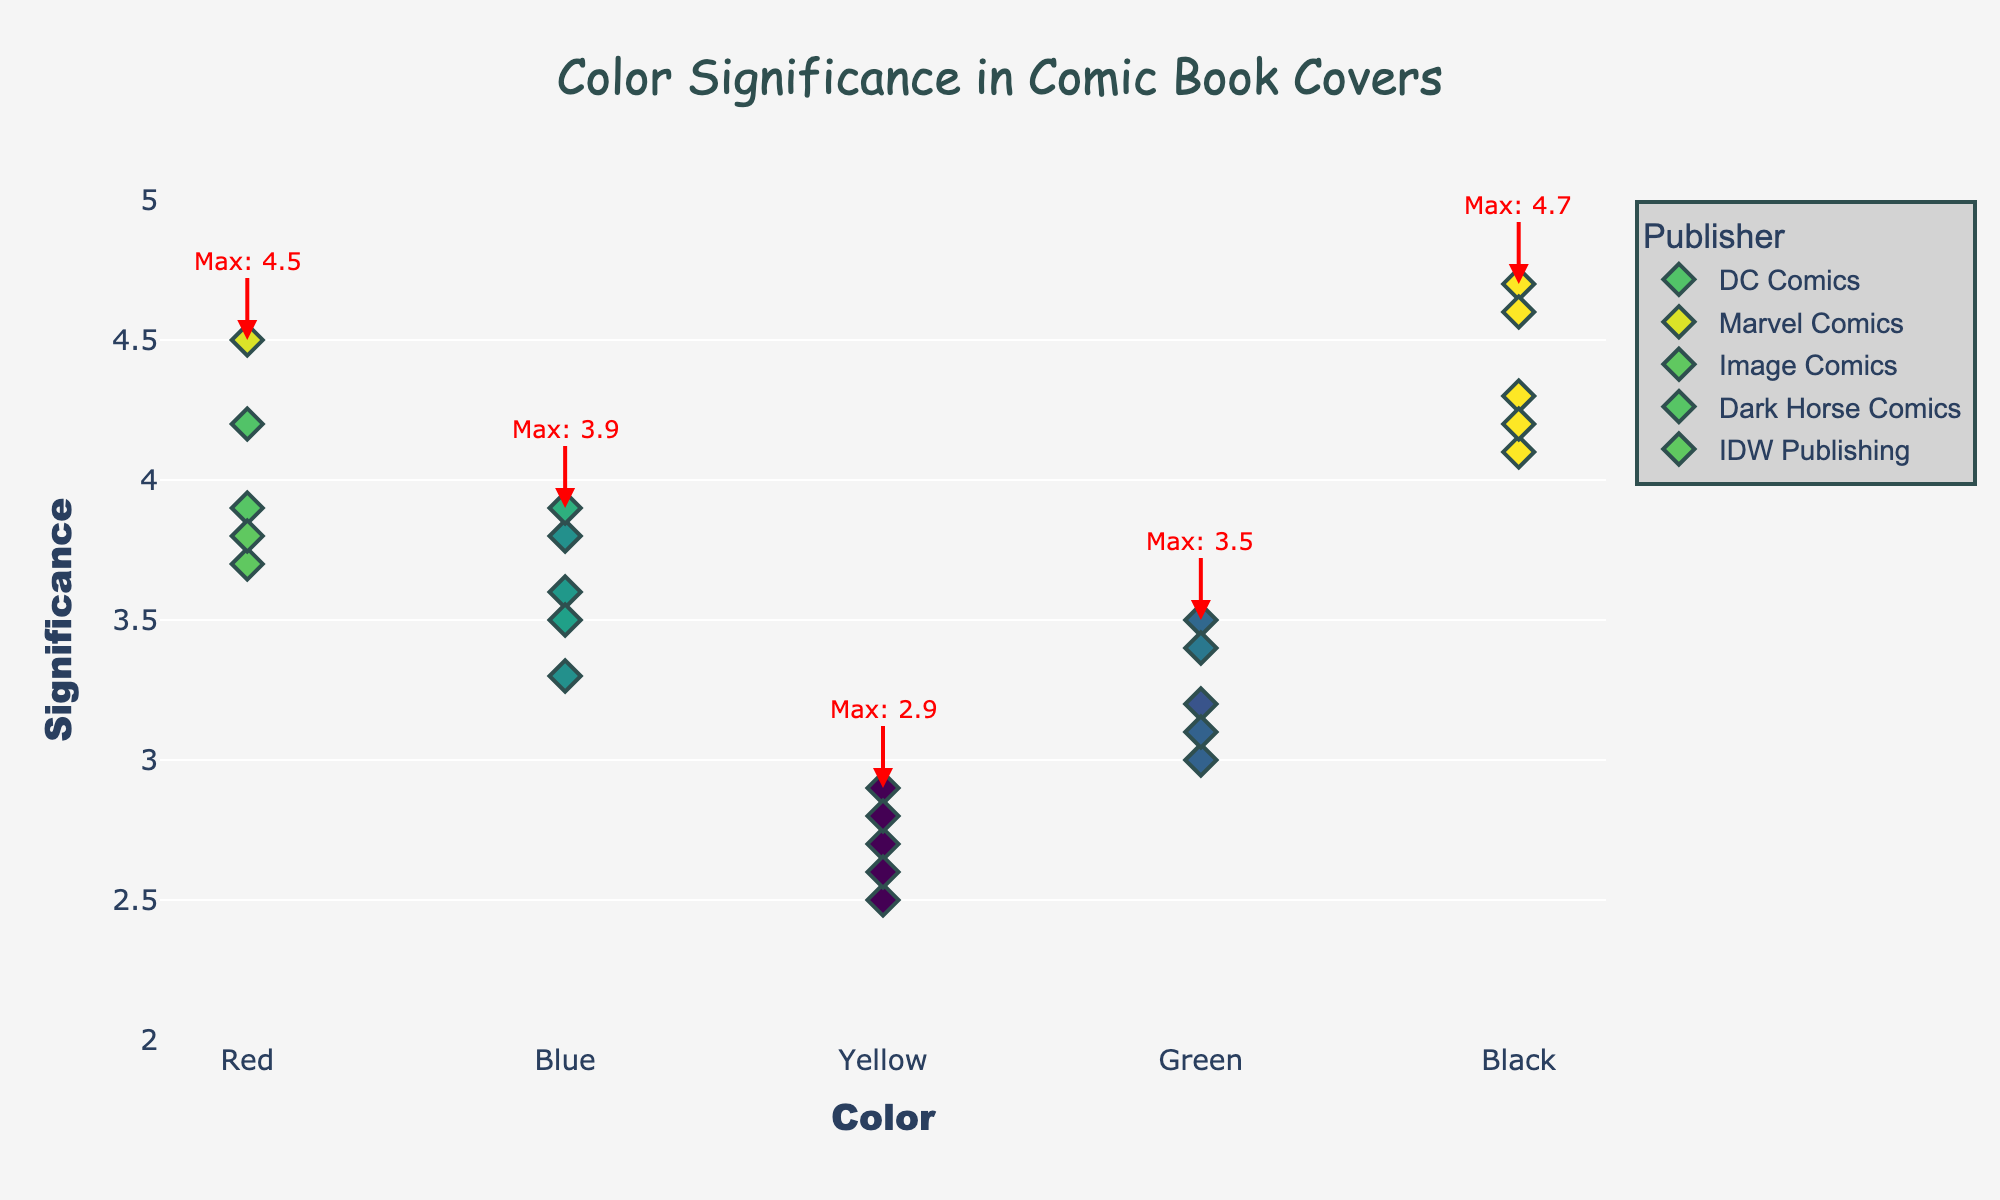What is the title of the plot? The title can be found at the top of the plot. It reads "Color Significance in Comic Book Covers".
Answer: Color Significance in Comic Book Covers Which publisher has the highest significance score for the color Red? Look for the highest point for 'Red' across all publishers and identify the corresponding publisher. The highest significance for Red is 4.5 by Marvel Comics.
Answer: Marvel Comics What is the significance range shown on the y-axis? The y-axis shows significance values, ranging from around 2 to 5. This can be inferred from the clearly marked ticks on the y-axis.
Answer: 2 to 5 Which color has the highest overall significance score and what is that score? Identify the highest significance value across all colors. The highest significance is for the color Black, with a score of 4.7.
Answer: Black, 4.7 How does the significance of Blue compare between DC Comics and Marvel Comics? Compare the y-values for Blue associated with each publisher. DC Comics has a significance of 3.8, while Marvel Comics has a significance of 3.9. Therefore, Marvel Comics has a slightly higher significance score for Blue than DC Comics.
Answer: Marvel Comics has a higher score What is the average significance score for the color Green across all publishers? Add up the significance scores for Green from all publishers and divide by the number of publishers. Scores: 3.5 (DC Comics), 3.2 (Marvel Comics), 3.0 (Image Comics), 3.4 (Dark Horse Comics), 3.1 (IDW Publishing). (3.5 + 3.2 + 3.0 + 3.4 + 3.1) / 5 = 3.24
Answer: 3.24 Which publisher has the lowest significance score for the color Yellow? Identify the lowest point for Yellow across all publishers. Image Comics has the lowest score of 2.5.
Answer: Image Comics What is the most significant color used by Dark Horse Comics and how significant is it? Locate the highest significance score for Dark Horse Comics and the corresponding color. The highest is Black with a significance of 4.3.
Answer: Black, 4.3 Compare the significance scores for DC Comics and Image Comics for the color Black. Which is higher and by how much? Determine the scores for Black: DC Comics is 4.7, Image Comics is 4.1. The difference is 4.7 - 4.1 = 0.6.
Answer: DC Comics by 0.6 